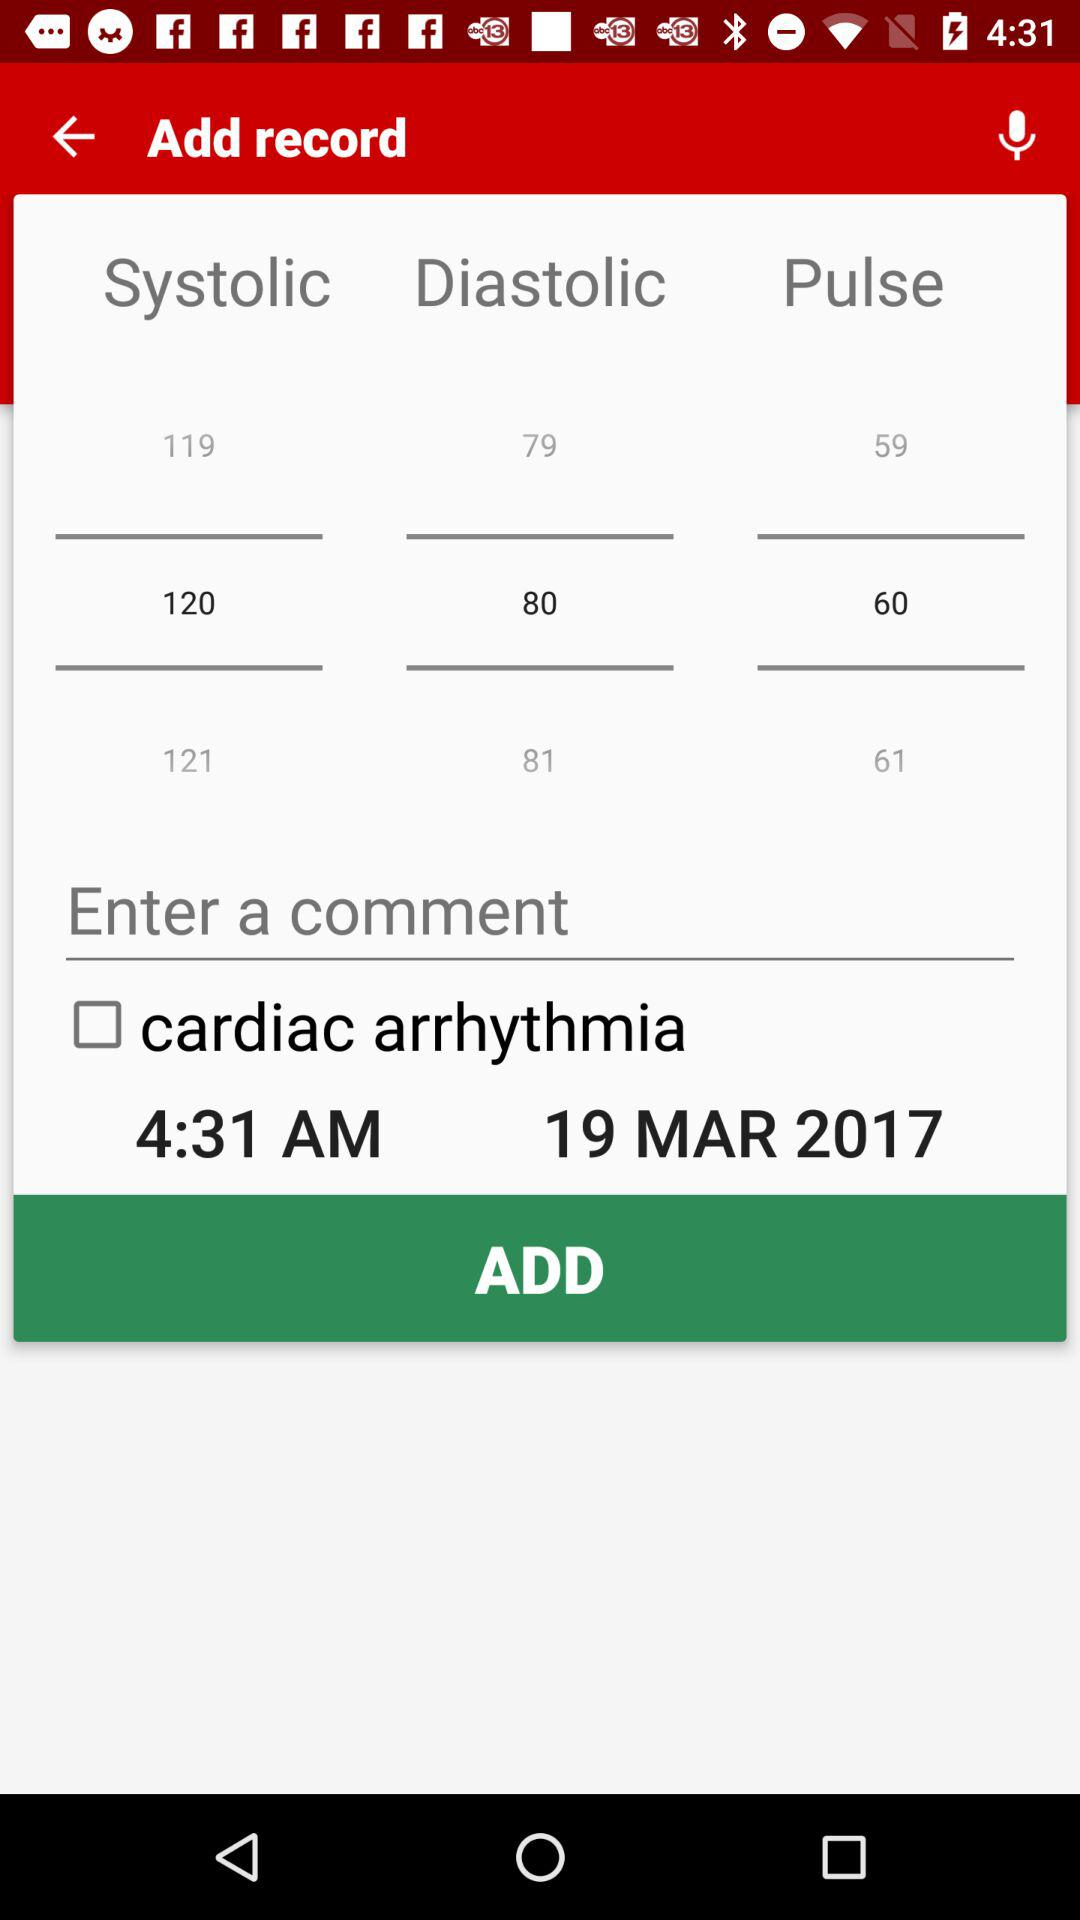What is the status of the "cardiac arrhythmia"? The status of the "cardiac arrhythmia" is "off". 